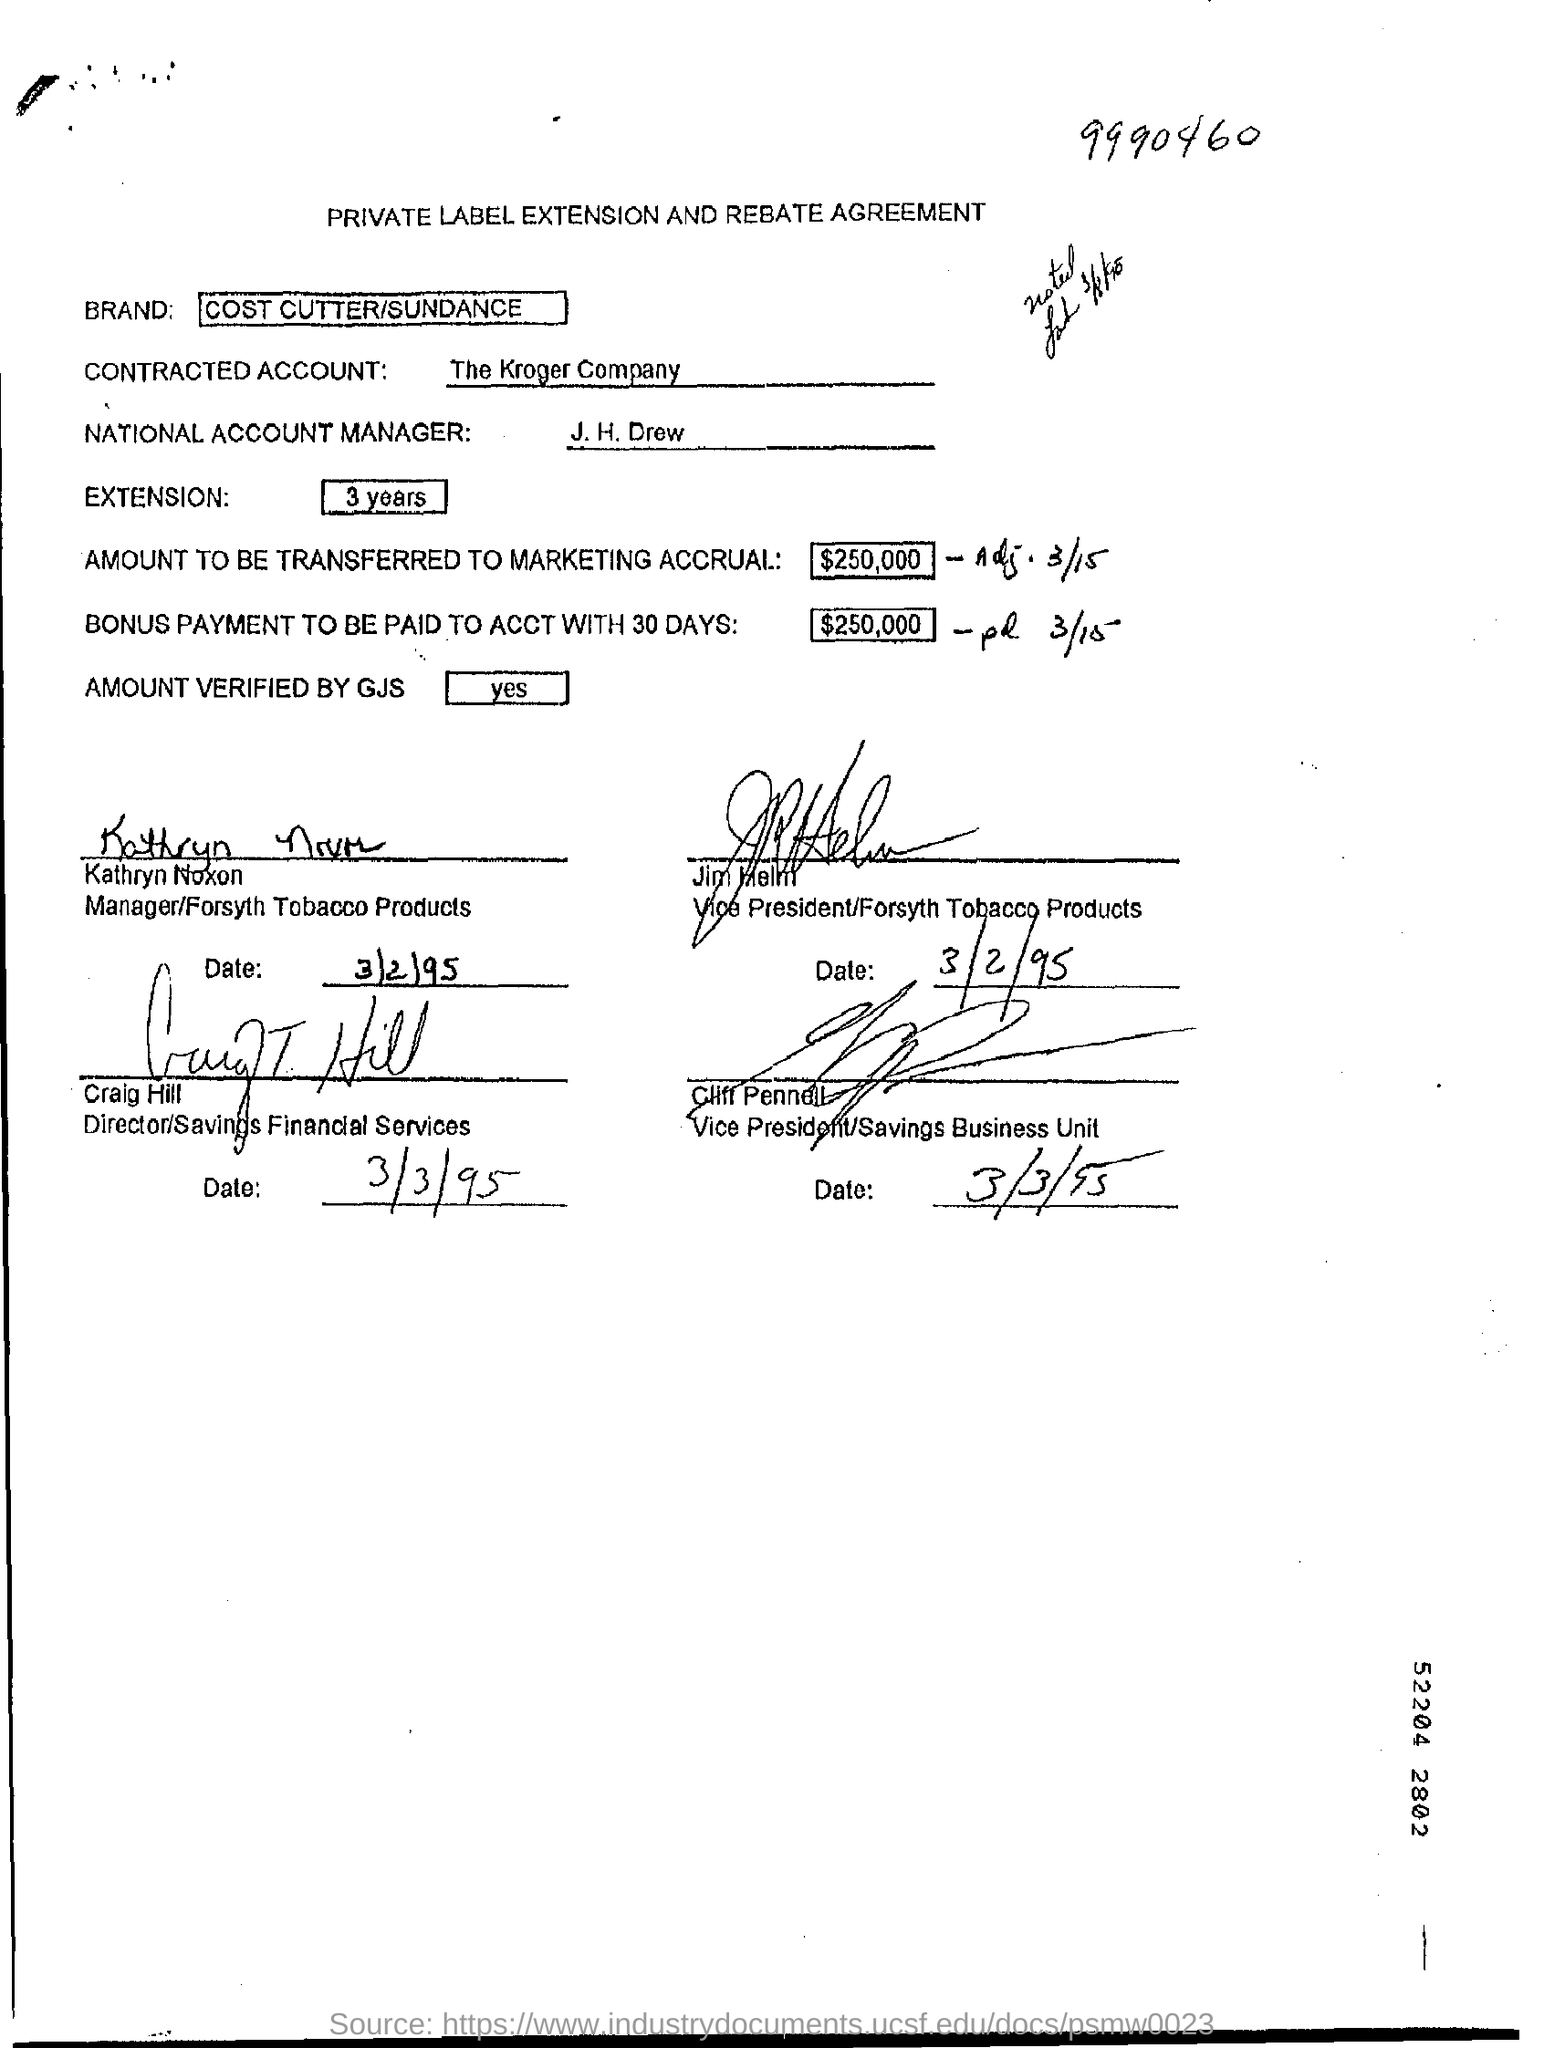What is the heading of the document?
Provide a succinct answer. PRIVATE LABEL EXTENSION AND REBATE AGREEMENT. What is the CONTRACTED ACCOUNT?
Your answer should be compact. The Kroger Company. What is the brand mentioned in the form?
Offer a terse response. COST CUTTER/SUNDANCE. 